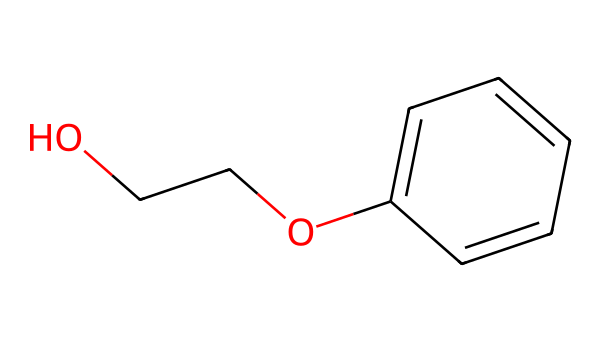What is the name of this chemical? The chemical structure has a recognizable arrangement of carbon, oxygen, and aromatic components, which matches the known structure of phenoxyethanol.
Answer: phenoxyethanol How many carbon atoms are in the structure? By examining the structure, we can count the number of carbon atoms. There are six in the aromatic ring (C1 to C6), plus two in the ethylene glycol structure (C7 and C8). Thus, the total is eight carbon atoms.
Answer: eight How many oxygen atoms are present? In the structure, there are two distinct oxygen atoms visible: one attached to the ethylene part and another forming the ether bond with the aromatic ring. Counting these gives a total of two oxygen atoms.
Answer: two What type of chemical bond connects the aromatic ring to ethylene glycol? The bond between the aromatic ring and the ethylene glycol part of the molecule is an ether bond, as indicated by the presence of an oxygen linking the two structures.
Answer: ether Why is phenoxyethanol used in hand sanitizers? Phenoxyethanol is effective as a preservative in hand sanitizers due to its antimicrobial properties, which help inhibit the growth of bacteria and fungi. This benefit is associated with its chemical structure that facilitates the disruption of microbial membranes.
Answer: antimicrobial properties Is this chemical polar or non-polar? Analyzing the functional groups present, such as hydroxyl and ether oxygen, the molecule has polar characteristics due to the presence of electronegative oxygen atoms, contributing to dipole moments. This makes phenoxyethanol polar overall.
Answer: polar 